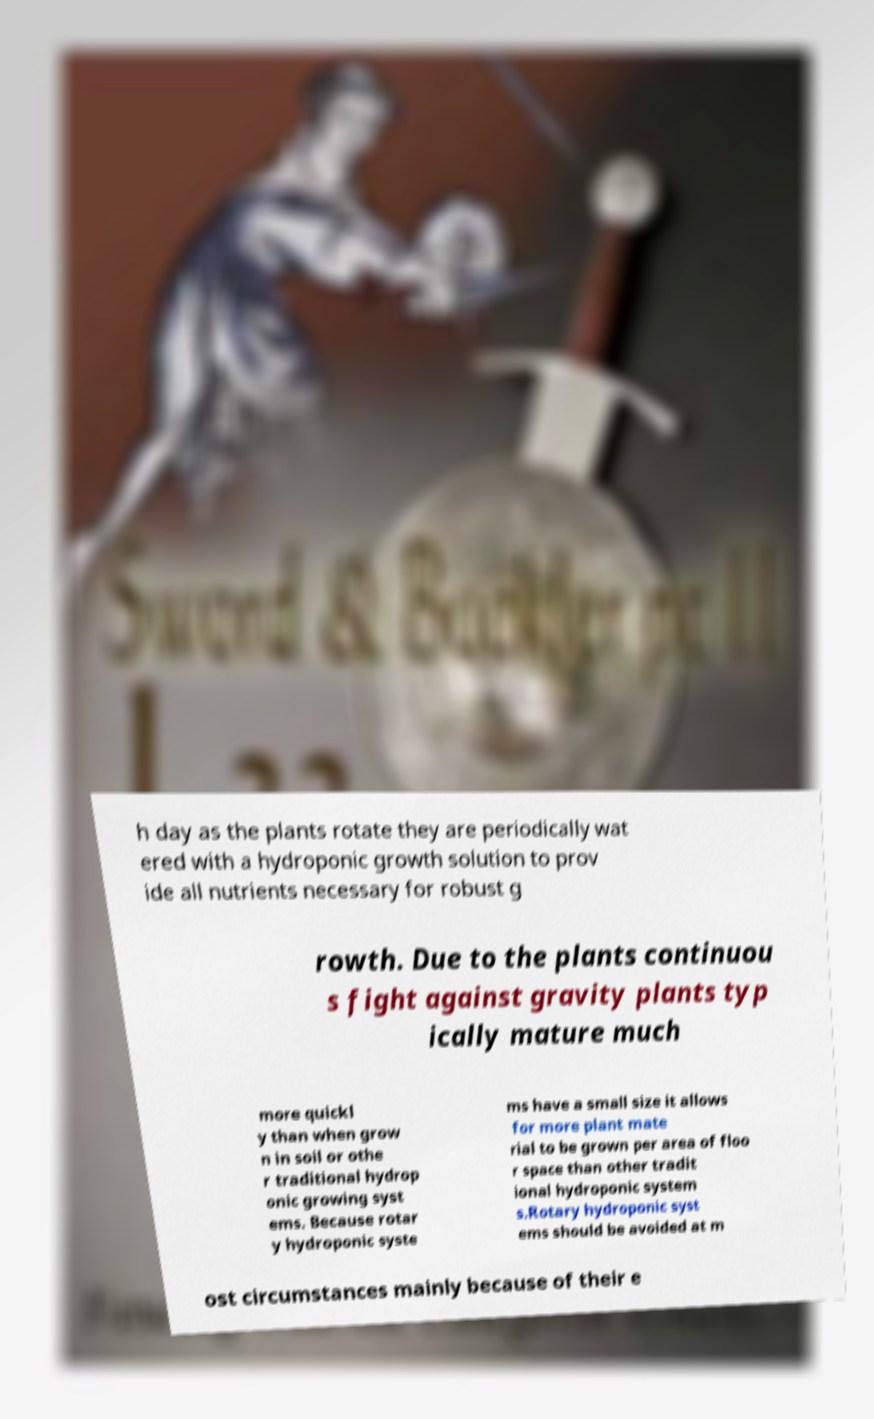Please read and relay the text visible in this image. What does it say? h day as the plants rotate they are periodically wat ered with a hydroponic growth solution to prov ide all nutrients necessary for robust g rowth. Due to the plants continuou s fight against gravity plants typ ically mature much more quickl y than when grow n in soil or othe r traditional hydrop onic growing syst ems. Because rotar y hydroponic syste ms have a small size it allows for more plant mate rial to be grown per area of floo r space than other tradit ional hydroponic system s.Rotary hydroponic syst ems should be avoided at m ost circumstances mainly because of their e 